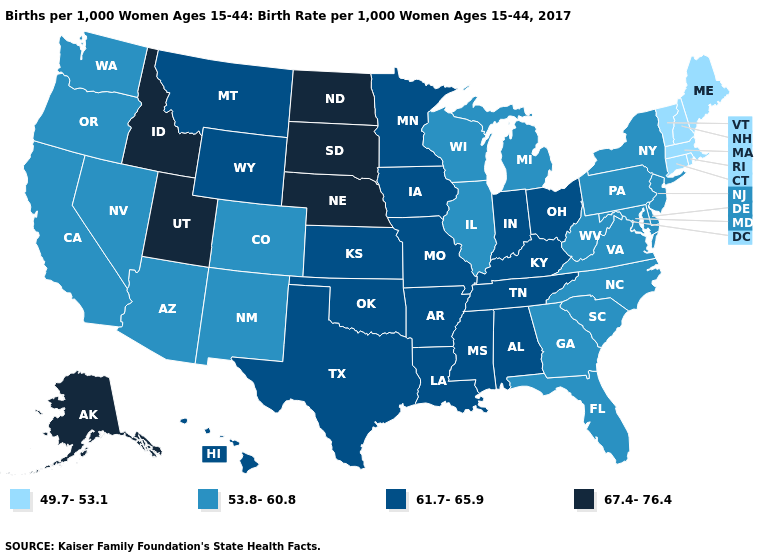What is the highest value in states that border Maryland?
Answer briefly. 53.8-60.8. Name the states that have a value in the range 67.4-76.4?
Be succinct. Alaska, Idaho, Nebraska, North Dakota, South Dakota, Utah. Does Delaware have the lowest value in the USA?
Short answer required. No. Name the states that have a value in the range 53.8-60.8?
Keep it brief. Arizona, California, Colorado, Delaware, Florida, Georgia, Illinois, Maryland, Michigan, Nevada, New Jersey, New Mexico, New York, North Carolina, Oregon, Pennsylvania, South Carolina, Virginia, Washington, West Virginia, Wisconsin. Name the states that have a value in the range 61.7-65.9?
Short answer required. Alabama, Arkansas, Hawaii, Indiana, Iowa, Kansas, Kentucky, Louisiana, Minnesota, Mississippi, Missouri, Montana, Ohio, Oklahoma, Tennessee, Texas, Wyoming. What is the value of North Dakota?
Quick response, please. 67.4-76.4. What is the value of New Hampshire?
Write a very short answer. 49.7-53.1. Name the states that have a value in the range 61.7-65.9?
Concise answer only. Alabama, Arkansas, Hawaii, Indiana, Iowa, Kansas, Kentucky, Louisiana, Minnesota, Mississippi, Missouri, Montana, Ohio, Oklahoma, Tennessee, Texas, Wyoming. What is the value of Pennsylvania?
Write a very short answer. 53.8-60.8. What is the value of Alaska?
Be succinct. 67.4-76.4. Does North Carolina have a lower value than Kansas?
Answer briefly. Yes. What is the lowest value in the Northeast?
Answer briefly. 49.7-53.1. What is the highest value in states that border Mississippi?
Short answer required. 61.7-65.9. Among the states that border Montana , which have the highest value?
Short answer required. Idaho, North Dakota, South Dakota. What is the value of Rhode Island?
Write a very short answer. 49.7-53.1. 